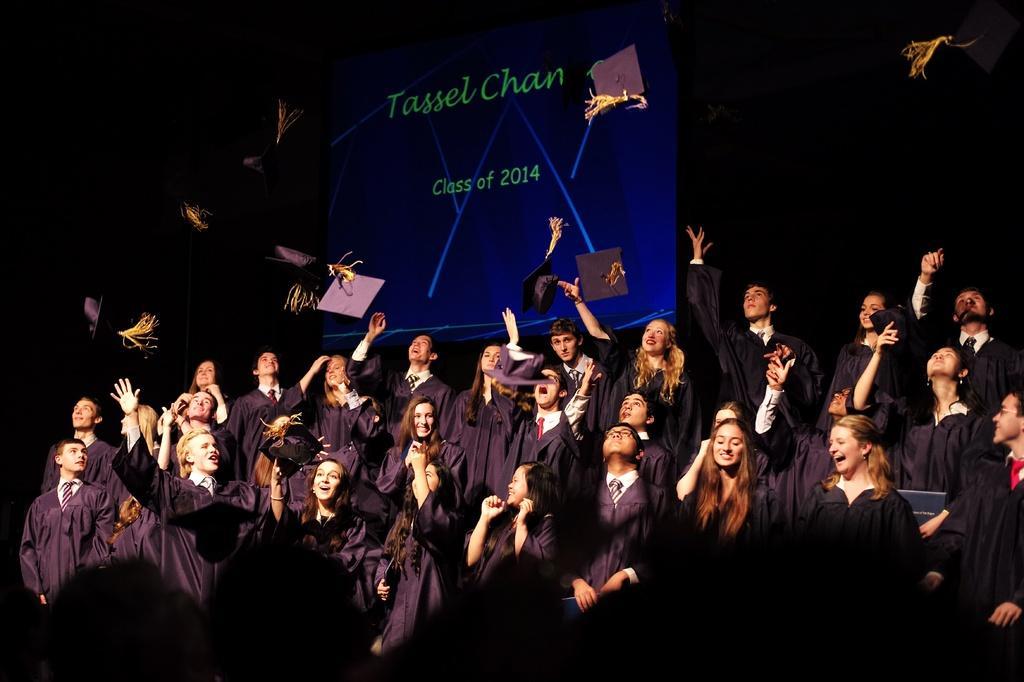How would you summarize this image in a sentence or two? In this image, we can see people wearing coats and some are throwing hats. In the background, there is a screen. 